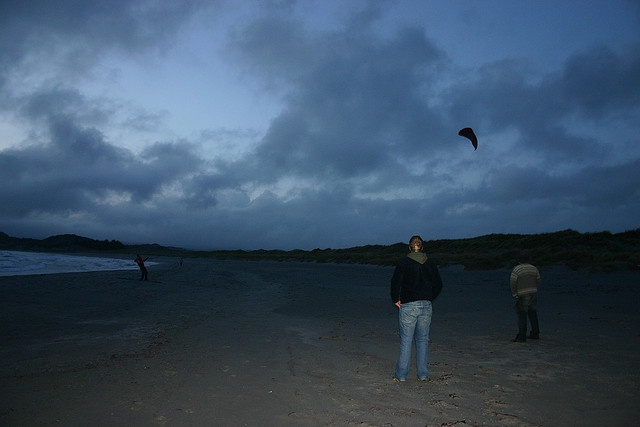Describe the objects in this image and their specific colors. I can see people in darkblue, black, and blue tones, people in darkblue, black, and gray tones, kite in darkblue, black, blue, navy, and gray tones, people in black, darkblue, and blue tones, and people in black and darkblue tones in this image. 